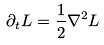Convert formula to latex. <formula><loc_0><loc_0><loc_500><loc_500>\partial _ { t } L = \frac { 1 } { 2 } \nabla ^ { 2 } L</formula> 